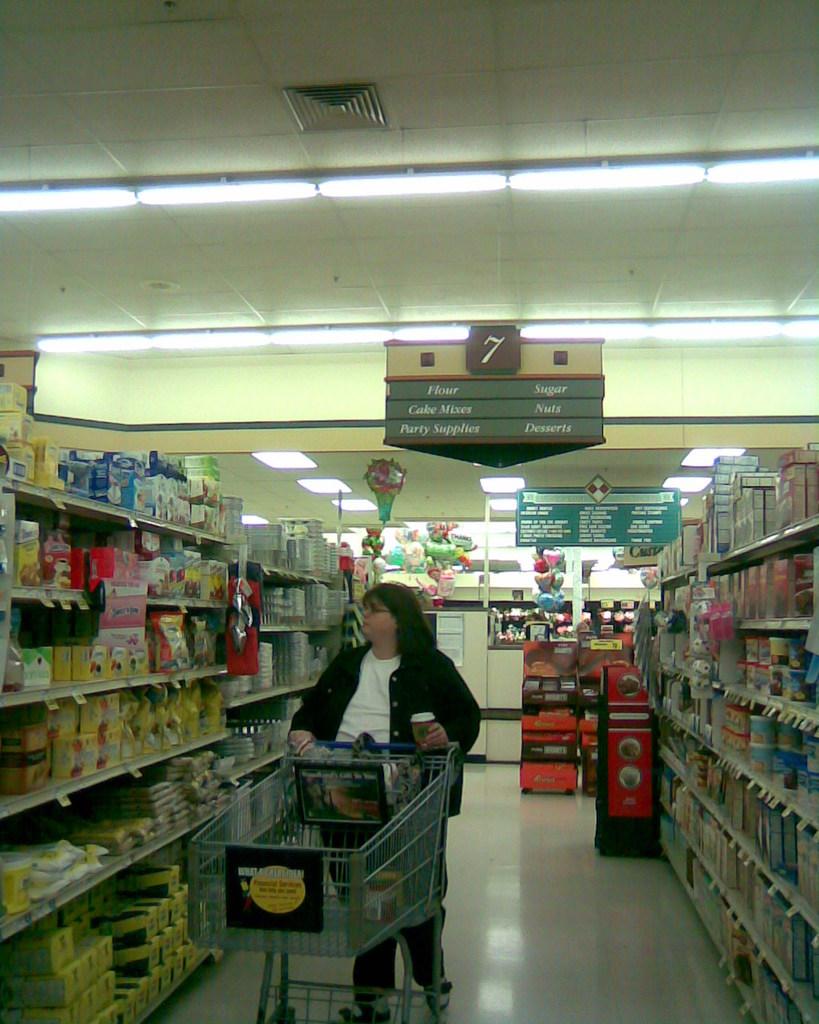What aisle is the woman in?
Make the answer very short. 7. Can you find party supplies on this aisle?
Your response must be concise. Yes. 